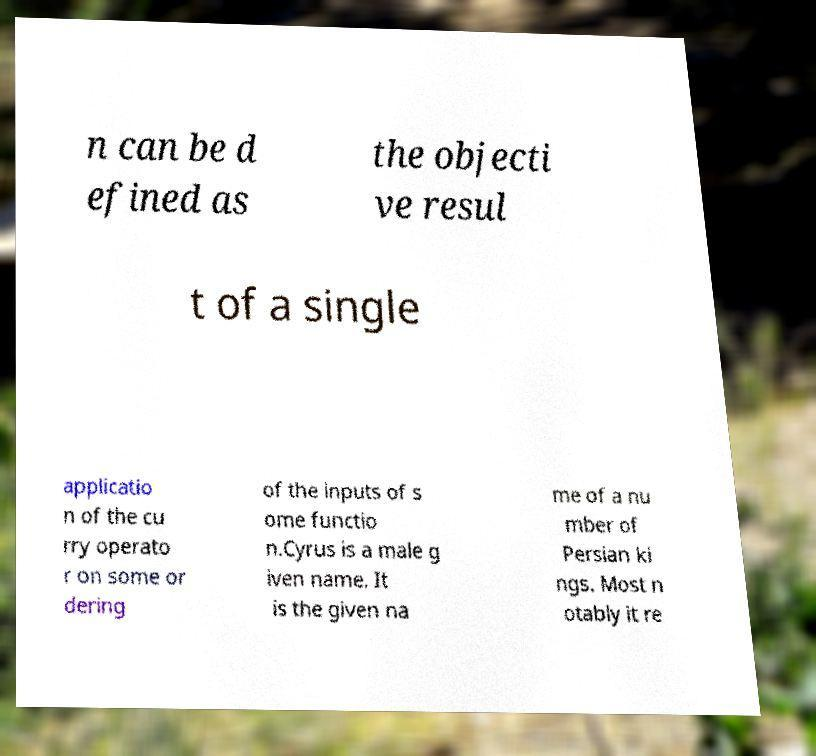I need the written content from this picture converted into text. Can you do that? n can be d efined as the objecti ve resul t of a single applicatio n of the cu rry operato r on some or dering of the inputs of s ome functio n.Cyrus is a male g iven name. It is the given na me of a nu mber of Persian ki ngs. Most n otably it re 